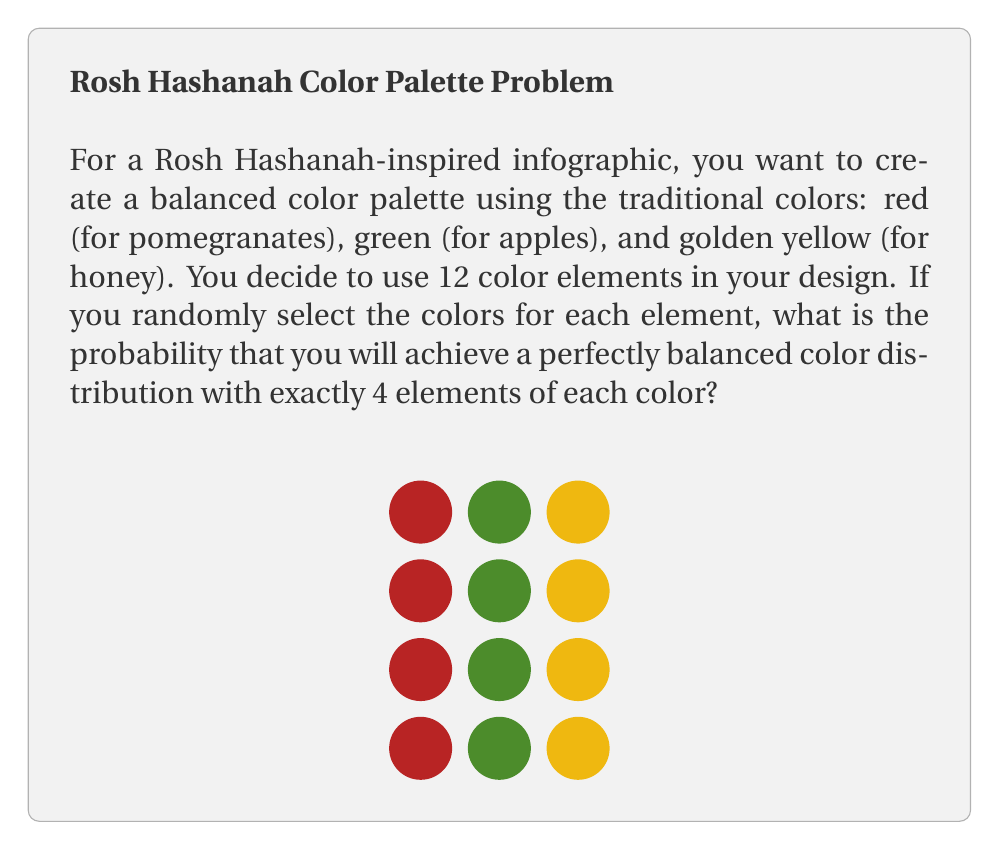Show me your answer to this math problem. Let's approach this step-by-step:

1) This problem follows a multinomial distribution, where we have 12 trials (color elements) and 3 possible outcomes (red, green, yellow) for each trial.

2) The probability of success for each color is 1/3, as we're selecting colors randomly.

3) We want exactly 4 of each color out of 12 elements.

4) The probability mass function for a multinomial distribution is:

   $$P(X_1 = x_1, X_2 = x_2, ..., X_k = x_k) = \frac{n!}{x_1! x_2! ... x_k!} p_1^{x_1} p_2^{x_2} ... p_k^{x_k}$$

   Where:
   - $n$ is the total number of trials (12 in our case)
   - $x_i$ is the number of successes for each outcome (4 for each color)
   - $p_i$ is the probability of each outcome (1/3 for each color)

5) Plugging in our values:

   $$P(X_{\text{red}} = 4, X_{\text{green}} = 4, X_{\text{yellow}} = 4) = \frac{12!}{4! 4! 4!} (\frac{1}{3})^4 (\frac{1}{3})^4 (\frac{1}{3})^4$$

6) Simplifying:

   $$= \frac{12!}{4! 4! 4!} (\frac{1}{3})^{12}$$

7) Calculate:
   
   $$= \frac{479,001,600}{24 \cdot 24 \cdot 24} \cdot \frac{1}{531,441}$$
   
   $$= 34,650 \cdot \frac{1}{531,441}$$
   
   $$= \frac{34,650}{531,441}$$
   
   $$\approx 0.0652 \text{ or about } 6.52\%$$
Answer: $\frac{34,650}{531,441} \approx 0.0652$ 